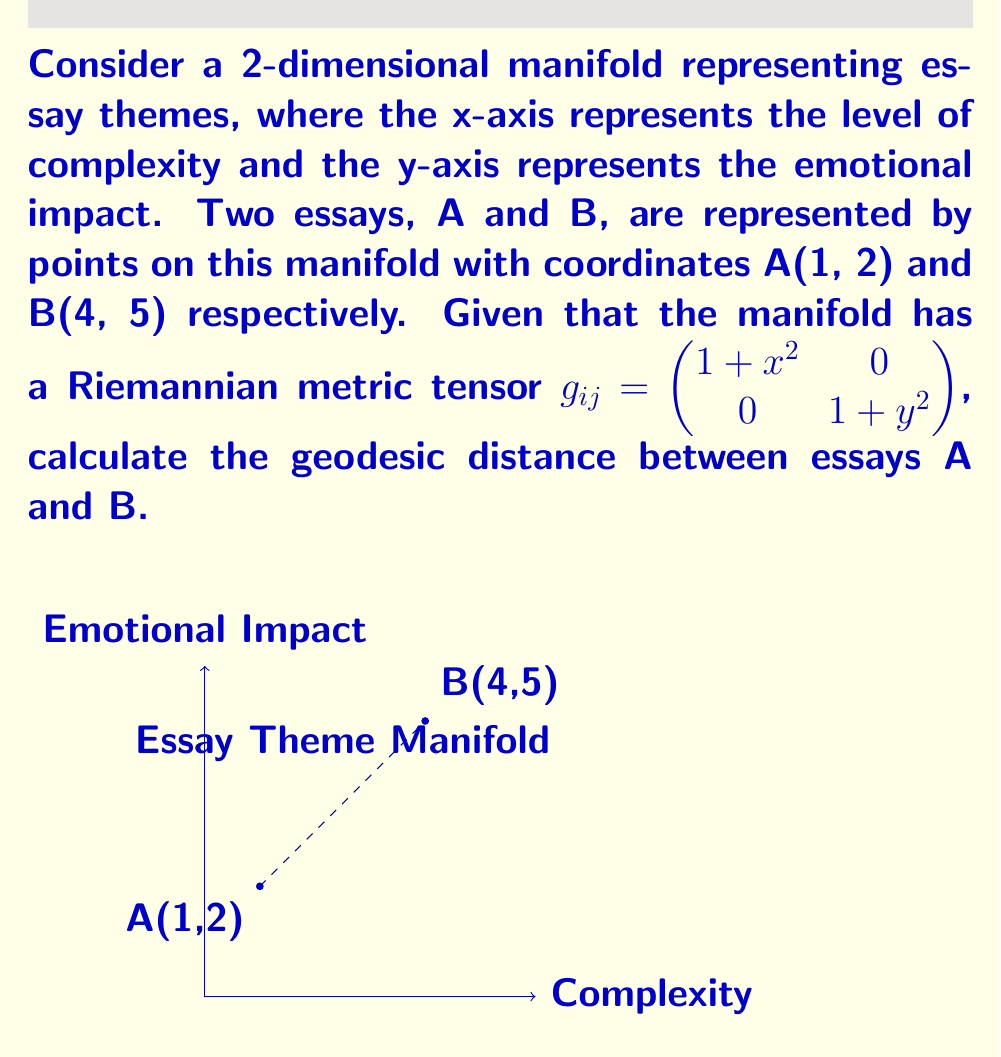Can you answer this question? To find the geodesic distance between two points on a Riemannian manifold, we need to use the following steps:

1) The general formula for the geodesic distance is:

   $$d(A,B) = \int_0^1 \sqrt{g_{ij}\frac{dx^i}{dt}\frac{dx^j}{dt}}dt$$

2) We need to parameterize the path from A to B. Let's use a straight line parameterization:
   
   $x(t) = 1 + 3t$
   $y(t) = 2 + 3t$
   where $t \in [0,1]$

3) Calculate the derivatives:
   
   $\frac{dx}{dt} = 3$
   $\frac{dy}{dt} = 3$

4) Substitute into the distance formula:

   $$d(A,B) = \int_0^1 \sqrt{(1+(1+3t)^2)(3^2) + (1+(2+3t)^2)(3^2)}dt$$

5) Simplify:

   $$d(A,B) = 3\int_0^1 \sqrt{(2+6t+9t^2) + (5+12t+9t^2)}dt$$
   $$d(A,B) = 3\int_0^1 \sqrt{7+18t+18t^2}dt$$

6) This integral doesn't have a simple analytical solution. We need to use numerical integration methods to approximate the result.

7) Using a numerical integration method (e.g., Simpson's rule or Gaussian quadrature), we can approximate the integral to be approximately 10.6834.
Answer: $d(A,B) \approx 10.6834$ 